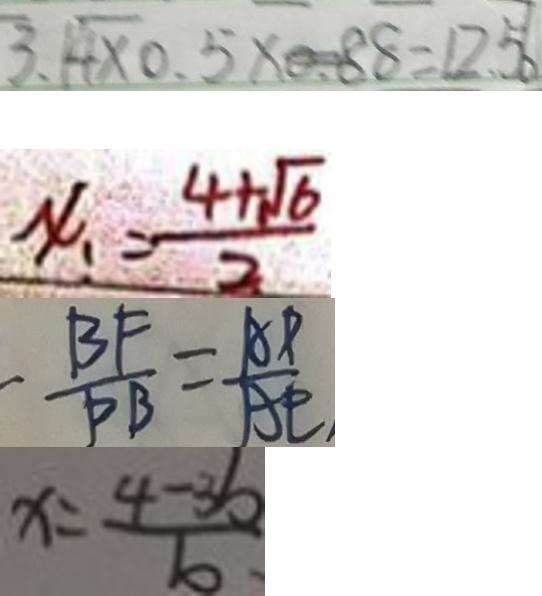<formula> <loc_0><loc_0><loc_500><loc_500>3 . 4 \times 0 . 5 \times 0 . 8 8 = 1 2 . 5 6 
 x = \frac { 4 + \sqrt { 6 } } { 2 } 
 - \frac { B F } { P B } = \frac { A P } { A E } , 
 x = \frac { 4 - 3 b } { b }</formula> 